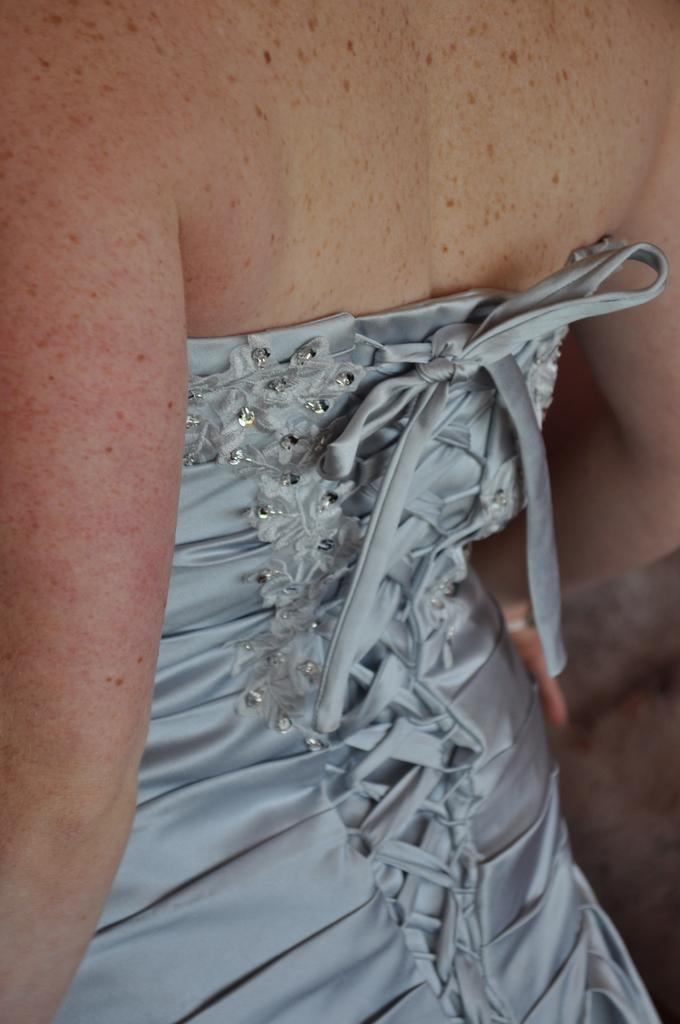What is the main subject of the image? The main subject of the image is the body of a person. What type of organization is depicted in the image? There is no organization depicted in the image; it features the body of a person. What can be found inside the can in the image? There is no can present in the image. 